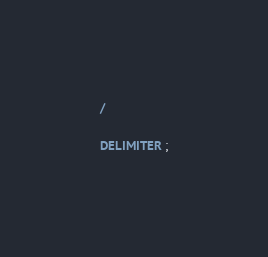<code> <loc_0><loc_0><loc_500><loc_500><_SQL_>/

DELIMITER ;
</code> 